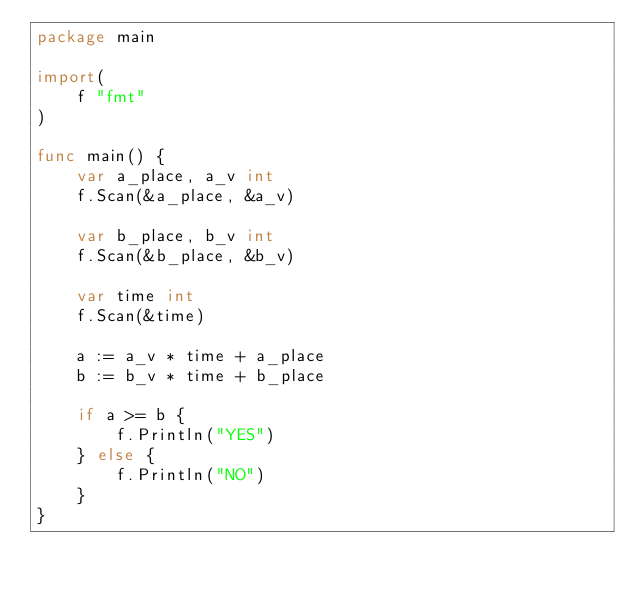Convert code to text. <code><loc_0><loc_0><loc_500><loc_500><_Go_>package main

import(
	f "fmt"
)

func main() {
	var a_place, a_v int
	f.Scan(&a_place, &a_v)

	var b_place, b_v int
	f.Scan(&b_place, &b_v)

	var time int
	f.Scan(&time)

	a := a_v * time + a_place
	b := b_v * time + b_place

	if a >= b {
		f.Println("YES")
	} else {
		f.Println("NO")
	}
}</code> 